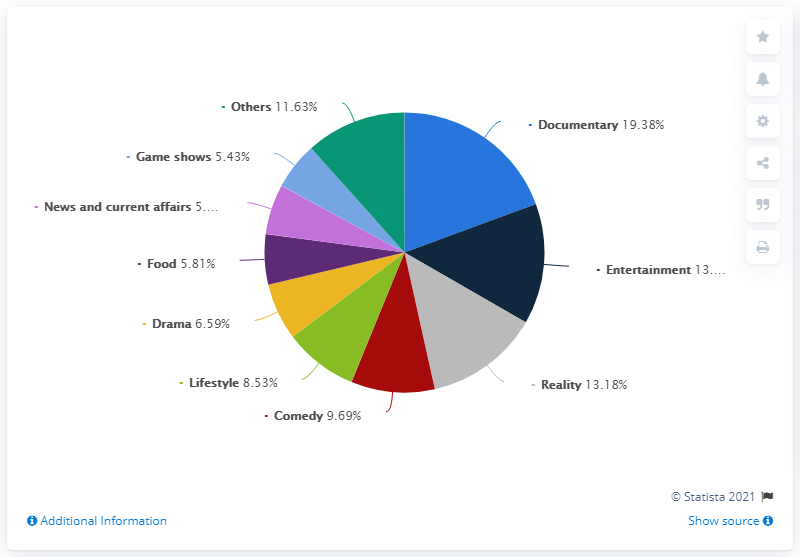Give some essential details in this illustration. It is estimated that 10 genres have been considered. Comedy is significantly greater than lifestyle, with a ratio of 1.16 to 1. 